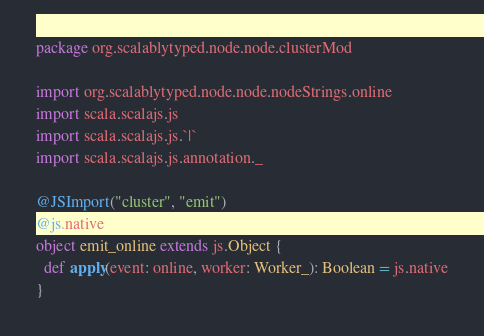Convert code to text. <code><loc_0><loc_0><loc_500><loc_500><_Scala_>package org.scalablytyped.node.node.clusterMod

import org.scalablytyped.node.node.nodeStrings.online
import scala.scalajs.js
import scala.scalajs.js.`|`
import scala.scalajs.js.annotation._

@JSImport("cluster", "emit")
@js.native
object emit_online extends js.Object {
  def apply(event: online, worker: Worker_): Boolean = js.native
}

</code> 